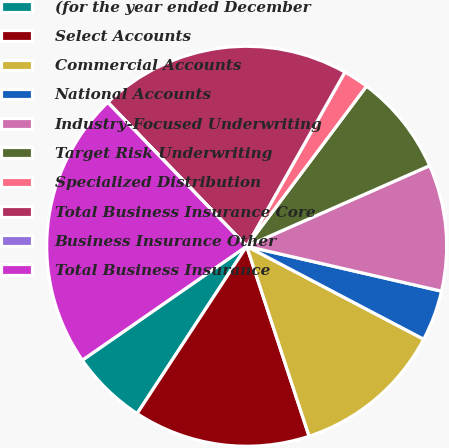<chart> <loc_0><loc_0><loc_500><loc_500><pie_chart><fcel>(for the year ended December<fcel>Select Accounts<fcel>Commercial Accounts<fcel>National Accounts<fcel>Industry-Focused Underwriting<fcel>Target Risk Underwriting<fcel>Specialized Distribution<fcel>Total Business Insurance Core<fcel>Business Insurance Other<fcel>Total Business Insurance<nl><fcel>6.13%<fcel>14.28%<fcel>12.25%<fcel>4.09%<fcel>10.21%<fcel>8.17%<fcel>2.05%<fcel>20.39%<fcel>0.01%<fcel>22.42%<nl></chart> 